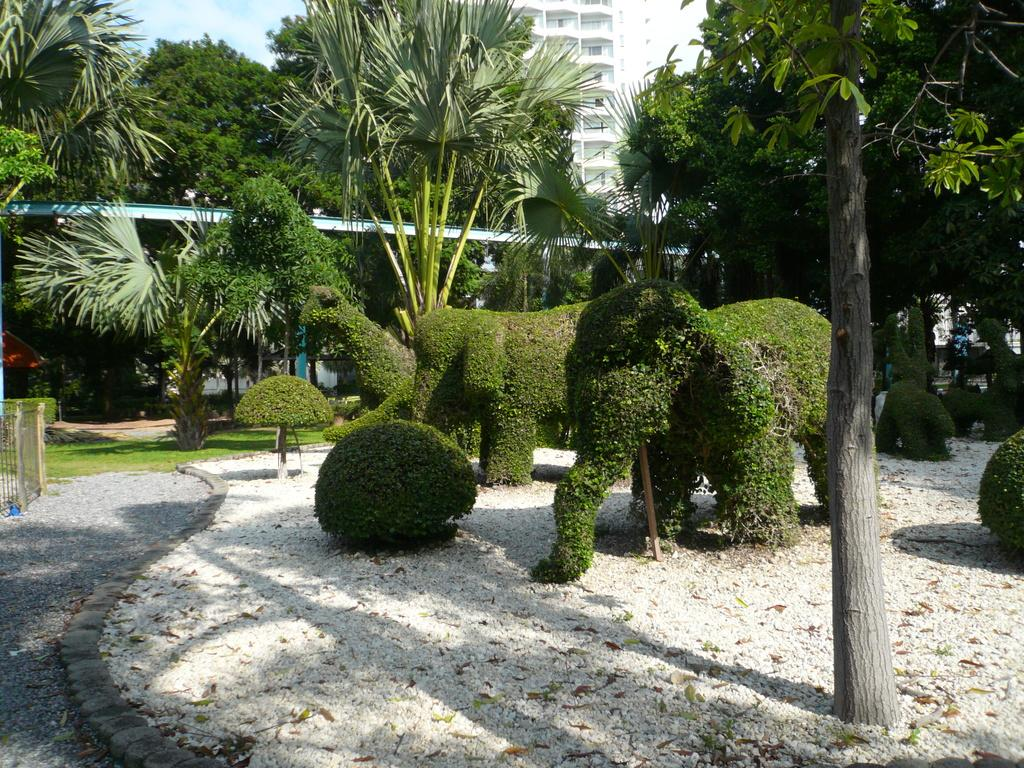What type of vegetation can be seen in the image? There are trees in the image. What is the color of the trees? The trees are green in color. What structure is visible in the background of the image? There is a building in the background of the image. What is the color of the building? The building is white in color. What part of the natural environment is visible in the image? The sky is visible in the image. What is the color of the sky? The sky is white in color. Where is the sofa located in the image? There is no sofa present in the image. Can you describe the mask that the trees are wearing in the image? There are no masks present in the image; the trees are simply green in color. 